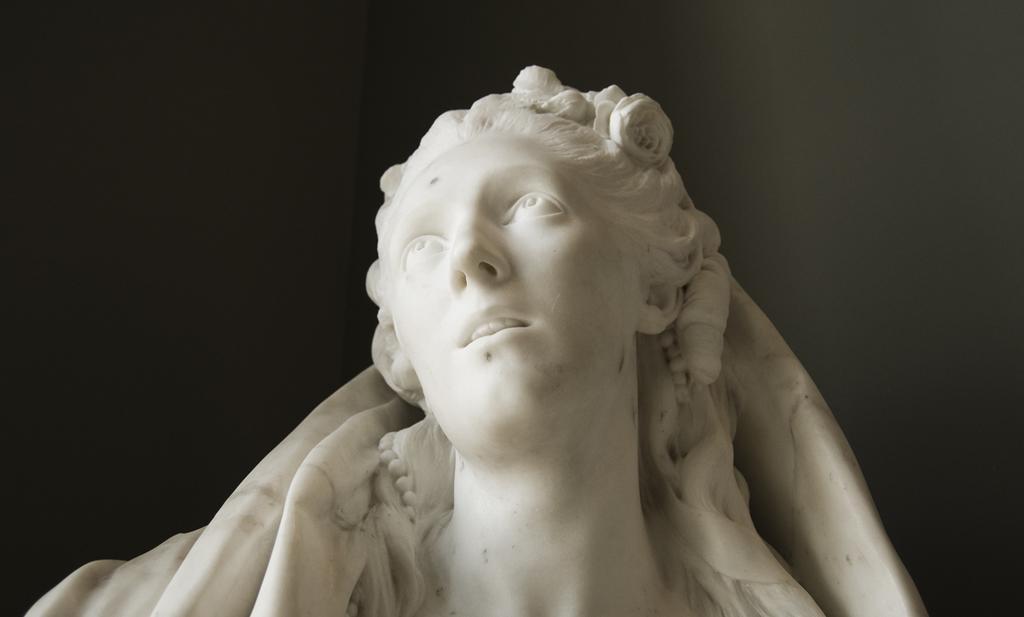Can you describe this image briefly? In the image there is a statue of a lady which is in white color. Behind statue there is a dark background. 